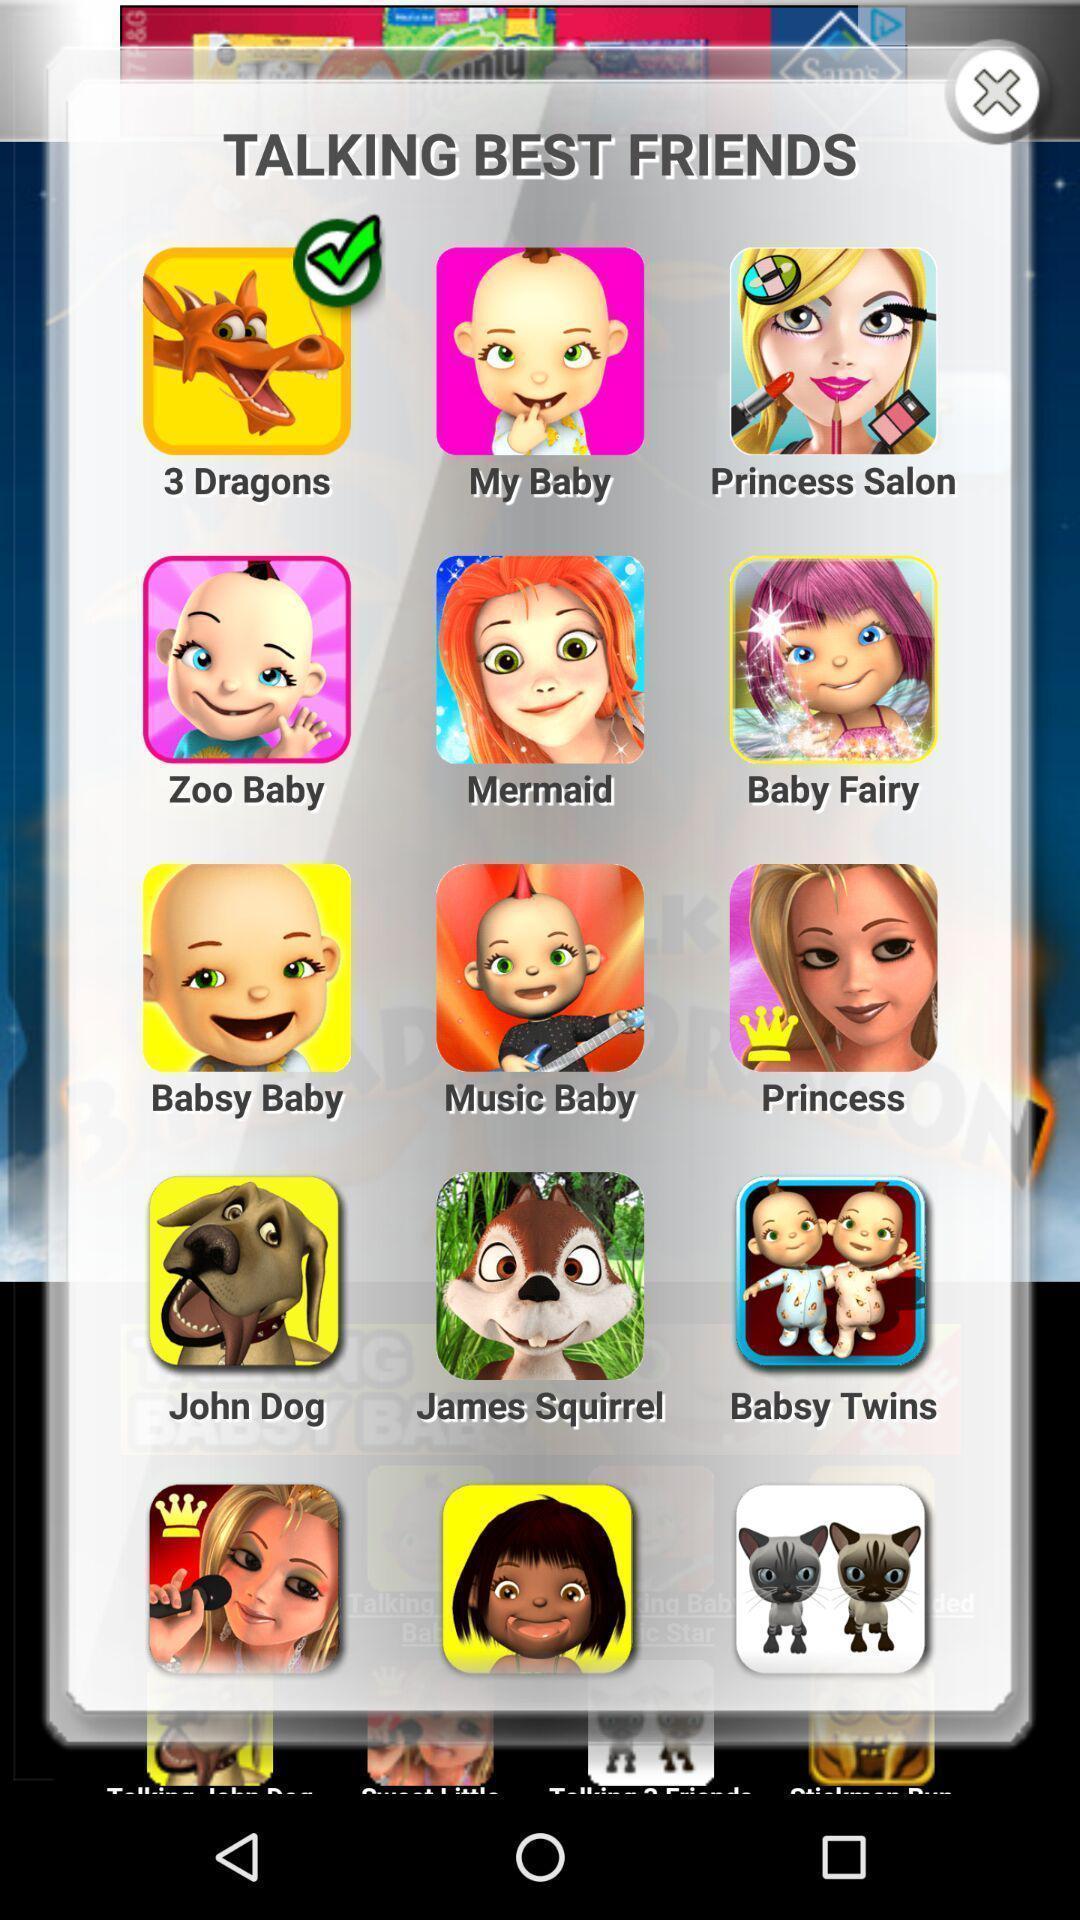Provide a textual representation of this image. Pop-up showing list of best friends in a gaming app. 